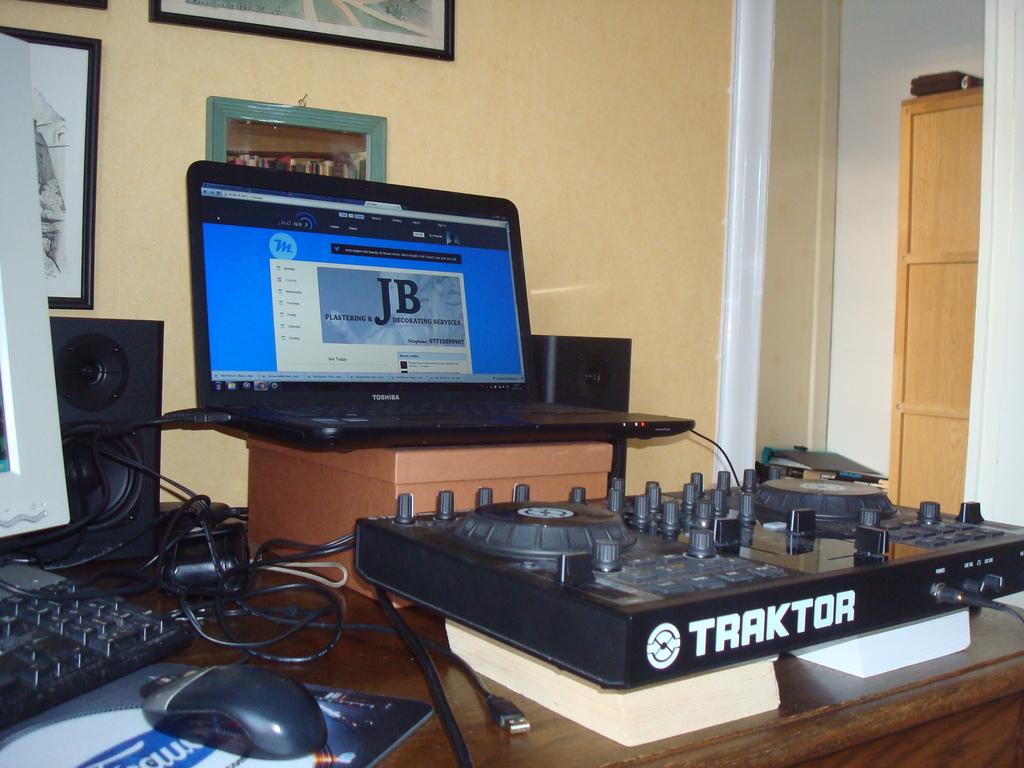Provide a one-sentence caption for the provided image. a computer open in front of a Traktor turn table. 